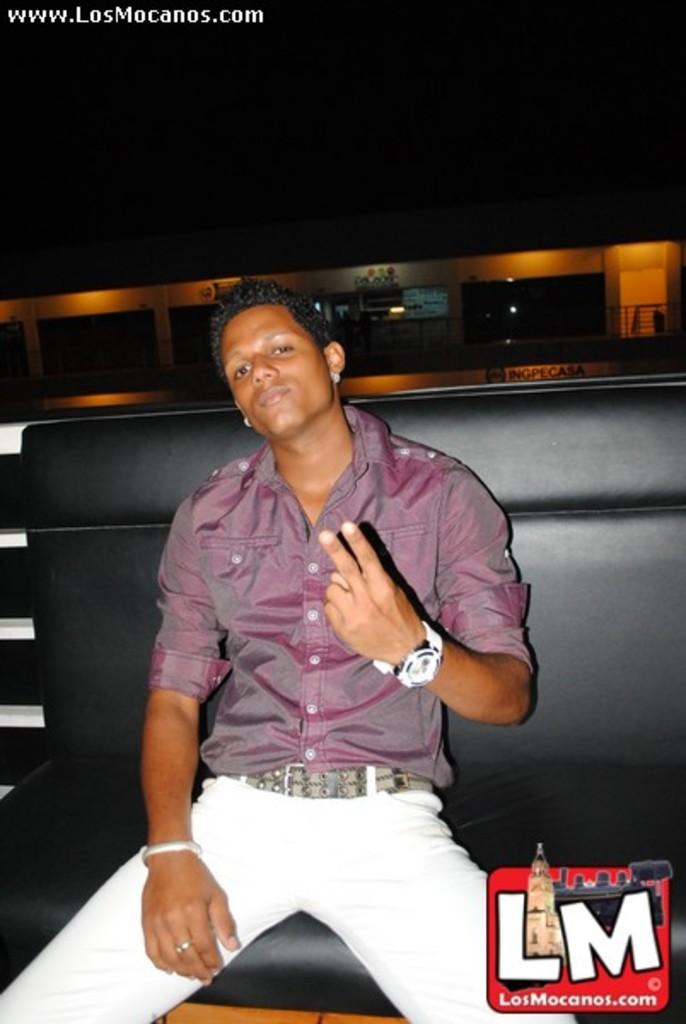What is the person in the image doing? There is a person sitting on a couch in the image. What color is the couch the person is sitting on? The couch is black in color. What can be seen in the image besides the person and the couch? There are lights visible in the image. What is the color of the background in the image? The background of the image is black. What type of shoes is the person wearing in the image? There is no information about shoes in the image, as the person is sitting on a couch and their feet are not visible. 